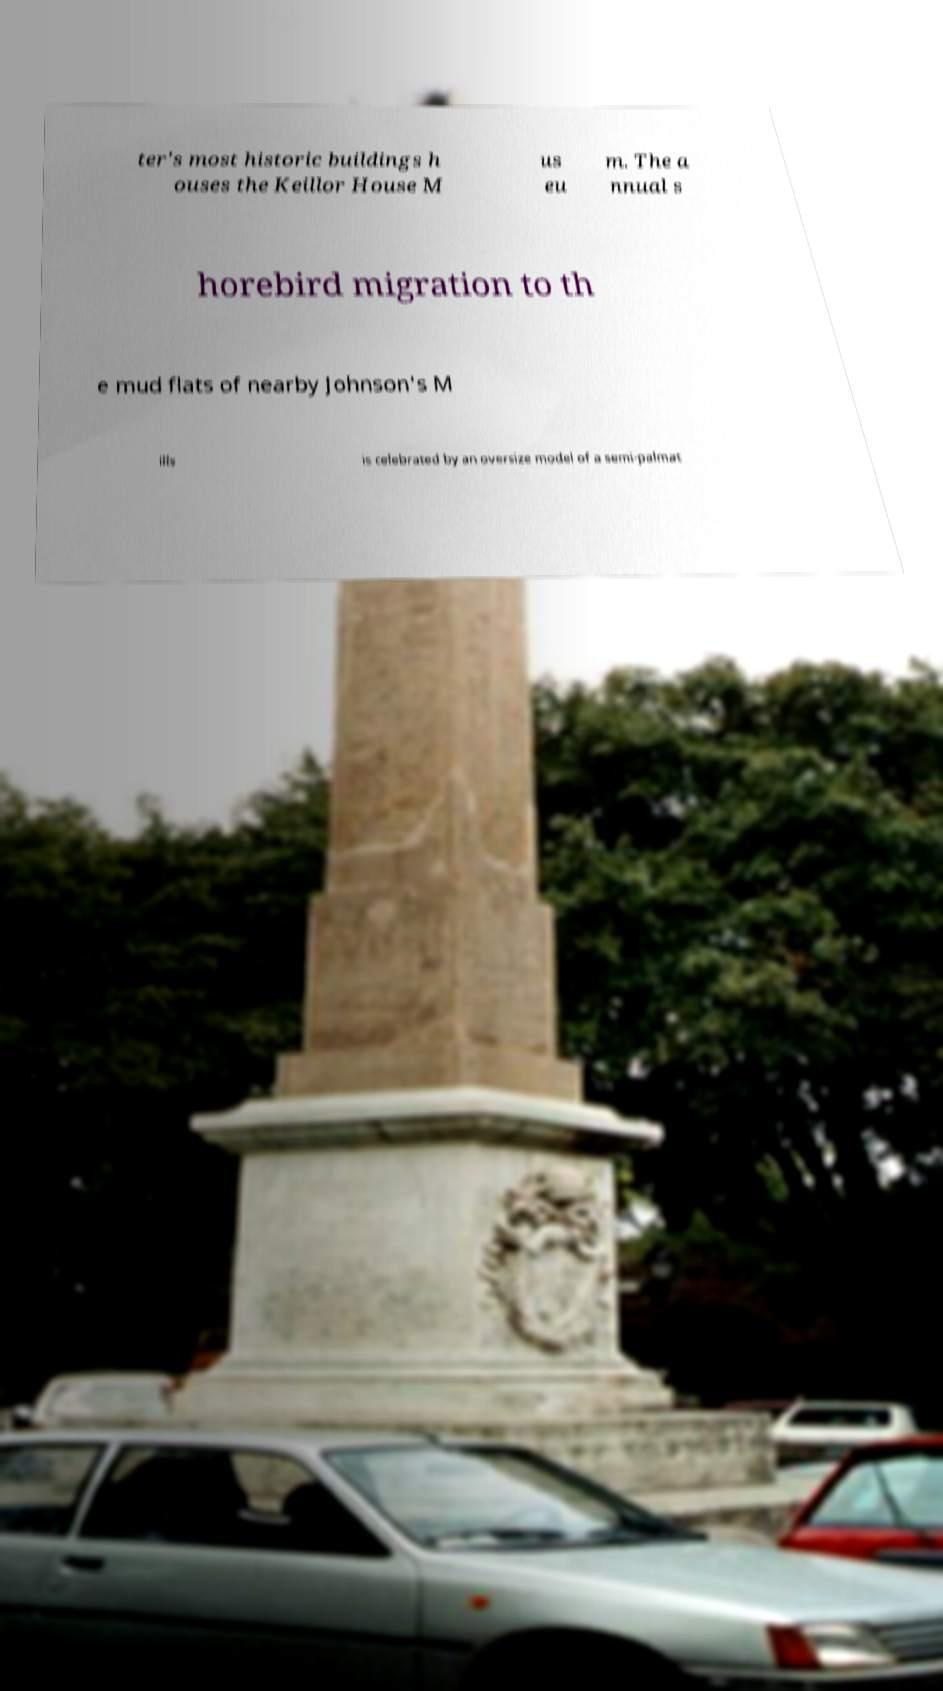What messages or text are displayed in this image? I need them in a readable, typed format. ter's most historic buildings h ouses the Keillor House M us eu m. The a nnual s horebird migration to th e mud flats of nearby Johnson's M ills is celebrated by an oversize model of a semi-palmat 